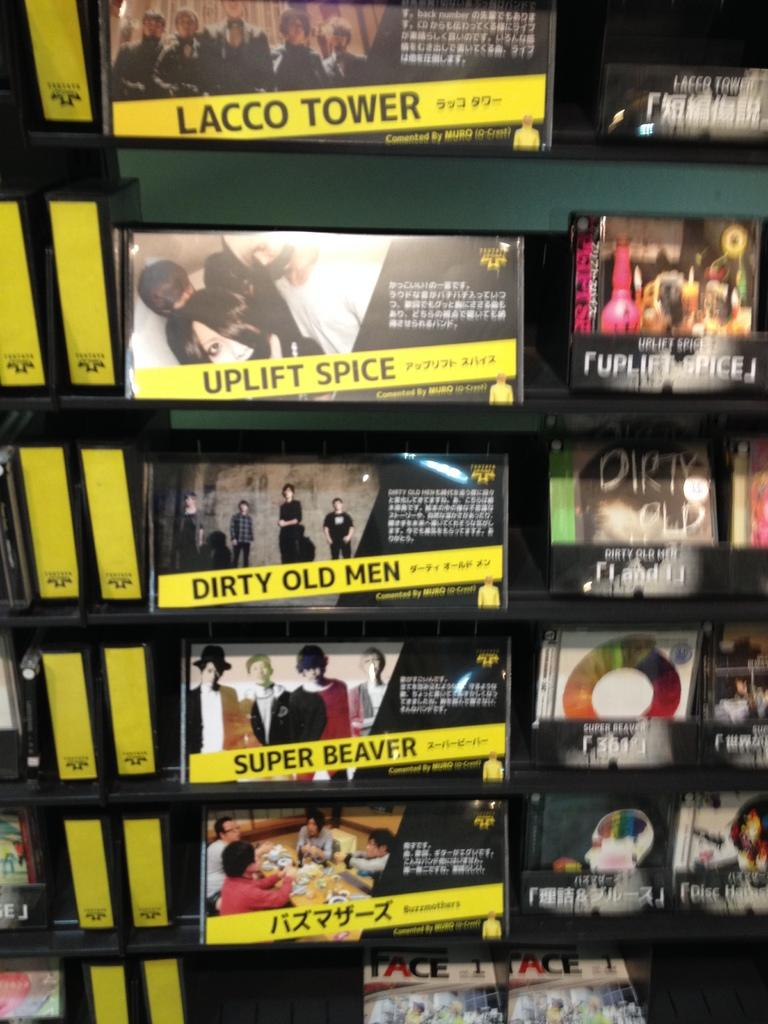<image>
Share a concise interpretation of the image provided. Some of the musical groups to choose from are Lacco Tower, Uplift Spice and Dirty Old Men. 